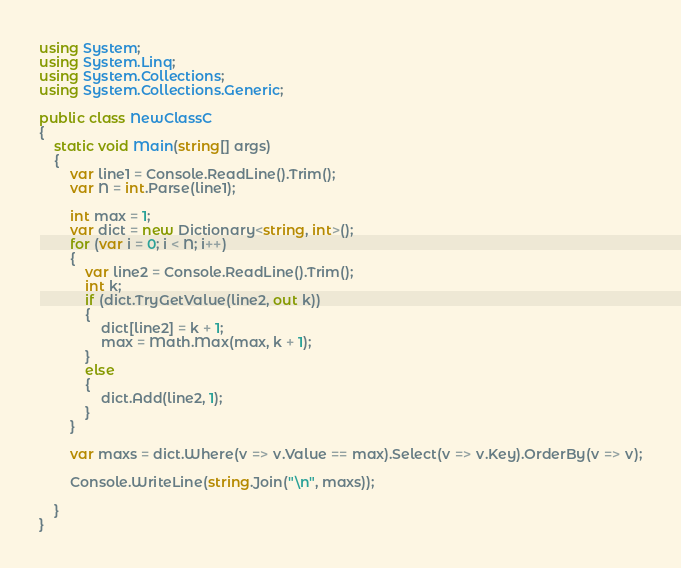<code> <loc_0><loc_0><loc_500><loc_500><_C#_>using System;
using System.Linq;
using System.Collections;
using System.Collections.Generic;

public class NewClassC
{
    static void Main(string[] args)
    {
        var line1 = Console.ReadLine().Trim();
        var N = int.Parse(line1);

        int max = 1;
        var dict = new Dictionary<string, int>();
        for (var i = 0; i < N; i++)
        {
            var line2 = Console.ReadLine().Trim();
            int k;
            if (dict.TryGetValue(line2, out k))
            {
                dict[line2] = k + 1;
                max = Math.Max(max, k + 1);
            }
            else
            {
                dict.Add(line2, 1);
            }
        }

        var maxs = dict.Where(v => v.Value == max).Select(v => v.Key).OrderBy(v => v);

        Console.WriteLine(string.Join("\n", maxs));

    }
}
</code> 